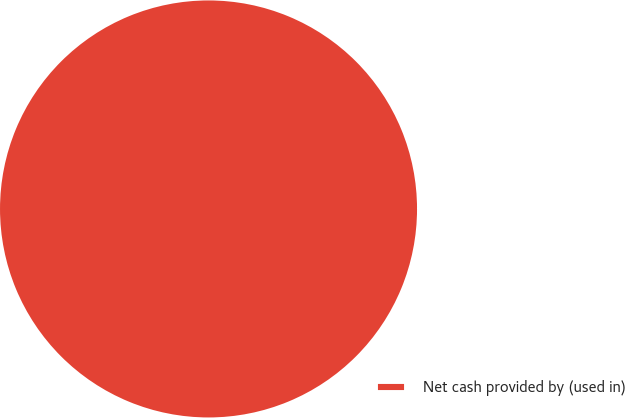<chart> <loc_0><loc_0><loc_500><loc_500><pie_chart><fcel>Net cash provided by (used in)<nl><fcel>100.0%<nl></chart> 